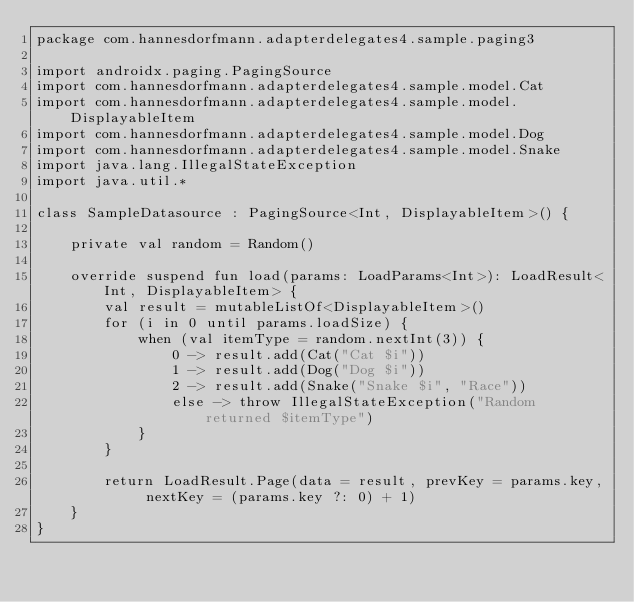<code> <loc_0><loc_0><loc_500><loc_500><_Kotlin_>package com.hannesdorfmann.adapterdelegates4.sample.paging3

import androidx.paging.PagingSource
import com.hannesdorfmann.adapterdelegates4.sample.model.Cat
import com.hannesdorfmann.adapterdelegates4.sample.model.DisplayableItem
import com.hannesdorfmann.adapterdelegates4.sample.model.Dog
import com.hannesdorfmann.adapterdelegates4.sample.model.Snake
import java.lang.IllegalStateException
import java.util.*

class SampleDatasource : PagingSource<Int, DisplayableItem>() {

    private val random = Random()

    override suspend fun load(params: LoadParams<Int>): LoadResult<Int, DisplayableItem> {
        val result = mutableListOf<DisplayableItem>()
        for (i in 0 until params.loadSize) {
            when (val itemType = random.nextInt(3)) {
                0 -> result.add(Cat("Cat $i"))
                1 -> result.add(Dog("Dog $i"))
                2 -> result.add(Snake("Snake $i", "Race"))
                else -> throw IllegalStateException("Random returned $itemType")
            }
        }

        return LoadResult.Page(data = result, prevKey = params.key, nextKey = (params.key ?: 0) + 1)
    }
}</code> 